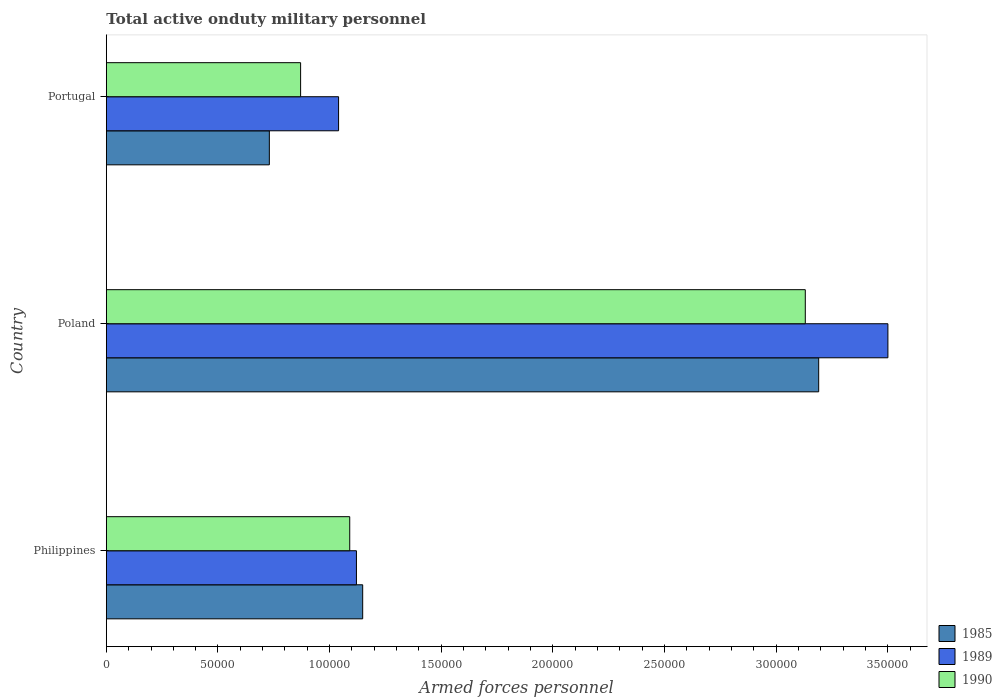How many groups of bars are there?
Your response must be concise. 3. Are the number of bars per tick equal to the number of legend labels?
Offer a very short reply. Yes. How many bars are there on the 3rd tick from the top?
Offer a terse response. 3. What is the label of the 2nd group of bars from the top?
Provide a short and direct response. Poland. What is the number of armed forces personnel in 1990 in Portugal?
Keep it short and to the point. 8.70e+04. Across all countries, what is the maximum number of armed forces personnel in 1985?
Your answer should be compact. 3.19e+05. Across all countries, what is the minimum number of armed forces personnel in 1985?
Your answer should be very brief. 7.30e+04. What is the total number of armed forces personnel in 1989 in the graph?
Give a very brief answer. 5.66e+05. What is the difference between the number of armed forces personnel in 1989 in Poland and that in Portugal?
Keep it short and to the point. 2.46e+05. What is the difference between the number of armed forces personnel in 1989 in Poland and the number of armed forces personnel in 1985 in Portugal?
Provide a short and direct response. 2.77e+05. What is the average number of armed forces personnel in 1989 per country?
Offer a very short reply. 1.89e+05. What is the difference between the number of armed forces personnel in 1985 and number of armed forces personnel in 1990 in Philippines?
Your answer should be very brief. 5800. In how many countries, is the number of armed forces personnel in 1989 greater than 190000 ?
Make the answer very short. 1. What is the ratio of the number of armed forces personnel in 1985 in Philippines to that in Portugal?
Your answer should be compact. 1.57. What is the difference between the highest and the second highest number of armed forces personnel in 1985?
Provide a succinct answer. 2.04e+05. What is the difference between the highest and the lowest number of armed forces personnel in 1990?
Provide a short and direct response. 2.26e+05. What does the 2nd bar from the bottom in Philippines represents?
Provide a short and direct response. 1989. What is the difference between two consecutive major ticks on the X-axis?
Your answer should be very brief. 5.00e+04. Are the values on the major ticks of X-axis written in scientific E-notation?
Give a very brief answer. No. Does the graph contain grids?
Offer a very short reply. No. Where does the legend appear in the graph?
Your answer should be very brief. Bottom right. What is the title of the graph?
Your answer should be compact. Total active onduty military personnel. What is the label or title of the X-axis?
Provide a short and direct response. Armed forces personnel. What is the label or title of the Y-axis?
Give a very brief answer. Country. What is the Armed forces personnel of 1985 in Philippines?
Your answer should be compact. 1.15e+05. What is the Armed forces personnel of 1989 in Philippines?
Your answer should be compact. 1.12e+05. What is the Armed forces personnel in 1990 in Philippines?
Keep it short and to the point. 1.09e+05. What is the Armed forces personnel of 1985 in Poland?
Your answer should be compact. 3.19e+05. What is the Armed forces personnel in 1989 in Poland?
Ensure brevity in your answer.  3.50e+05. What is the Armed forces personnel in 1990 in Poland?
Your response must be concise. 3.13e+05. What is the Armed forces personnel in 1985 in Portugal?
Offer a very short reply. 7.30e+04. What is the Armed forces personnel of 1989 in Portugal?
Provide a short and direct response. 1.04e+05. What is the Armed forces personnel in 1990 in Portugal?
Offer a terse response. 8.70e+04. Across all countries, what is the maximum Armed forces personnel in 1985?
Your answer should be very brief. 3.19e+05. Across all countries, what is the maximum Armed forces personnel in 1989?
Provide a succinct answer. 3.50e+05. Across all countries, what is the maximum Armed forces personnel in 1990?
Provide a short and direct response. 3.13e+05. Across all countries, what is the minimum Armed forces personnel in 1985?
Ensure brevity in your answer.  7.30e+04. Across all countries, what is the minimum Armed forces personnel of 1989?
Ensure brevity in your answer.  1.04e+05. Across all countries, what is the minimum Armed forces personnel of 1990?
Your answer should be very brief. 8.70e+04. What is the total Armed forces personnel of 1985 in the graph?
Your answer should be compact. 5.07e+05. What is the total Armed forces personnel in 1989 in the graph?
Ensure brevity in your answer.  5.66e+05. What is the total Armed forces personnel in 1990 in the graph?
Your response must be concise. 5.09e+05. What is the difference between the Armed forces personnel in 1985 in Philippines and that in Poland?
Provide a succinct answer. -2.04e+05. What is the difference between the Armed forces personnel in 1989 in Philippines and that in Poland?
Provide a short and direct response. -2.38e+05. What is the difference between the Armed forces personnel in 1990 in Philippines and that in Poland?
Offer a terse response. -2.04e+05. What is the difference between the Armed forces personnel of 1985 in Philippines and that in Portugal?
Offer a very short reply. 4.18e+04. What is the difference between the Armed forces personnel of 1989 in Philippines and that in Portugal?
Offer a very short reply. 8000. What is the difference between the Armed forces personnel in 1990 in Philippines and that in Portugal?
Your response must be concise. 2.20e+04. What is the difference between the Armed forces personnel of 1985 in Poland and that in Portugal?
Provide a short and direct response. 2.46e+05. What is the difference between the Armed forces personnel in 1989 in Poland and that in Portugal?
Ensure brevity in your answer.  2.46e+05. What is the difference between the Armed forces personnel in 1990 in Poland and that in Portugal?
Make the answer very short. 2.26e+05. What is the difference between the Armed forces personnel of 1985 in Philippines and the Armed forces personnel of 1989 in Poland?
Ensure brevity in your answer.  -2.35e+05. What is the difference between the Armed forces personnel in 1985 in Philippines and the Armed forces personnel in 1990 in Poland?
Keep it short and to the point. -1.98e+05. What is the difference between the Armed forces personnel of 1989 in Philippines and the Armed forces personnel of 1990 in Poland?
Your response must be concise. -2.01e+05. What is the difference between the Armed forces personnel in 1985 in Philippines and the Armed forces personnel in 1989 in Portugal?
Ensure brevity in your answer.  1.08e+04. What is the difference between the Armed forces personnel in 1985 in Philippines and the Armed forces personnel in 1990 in Portugal?
Offer a terse response. 2.78e+04. What is the difference between the Armed forces personnel of 1989 in Philippines and the Armed forces personnel of 1990 in Portugal?
Offer a terse response. 2.50e+04. What is the difference between the Armed forces personnel in 1985 in Poland and the Armed forces personnel in 1989 in Portugal?
Make the answer very short. 2.15e+05. What is the difference between the Armed forces personnel of 1985 in Poland and the Armed forces personnel of 1990 in Portugal?
Your answer should be very brief. 2.32e+05. What is the difference between the Armed forces personnel in 1989 in Poland and the Armed forces personnel in 1990 in Portugal?
Provide a succinct answer. 2.63e+05. What is the average Armed forces personnel of 1985 per country?
Keep it short and to the point. 1.69e+05. What is the average Armed forces personnel of 1989 per country?
Ensure brevity in your answer.  1.89e+05. What is the average Armed forces personnel of 1990 per country?
Your answer should be compact. 1.70e+05. What is the difference between the Armed forces personnel in 1985 and Armed forces personnel in 1989 in Philippines?
Keep it short and to the point. 2800. What is the difference between the Armed forces personnel in 1985 and Armed forces personnel in 1990 in Philippines?
Offer a very short reply. 5800. What is the difference between the Armed forces personnel of 1989 and Armed forces personnel of 1990 in Philippines?
Offer a terse response. 3000. What is the difference between the Armed forces personnel in 1985 and Armed forces personnel in 1989 in Poland?
Provide a succinct answer. -3.10e+04. What is the difference between the Armed forces personnel in 1985 and Armed forces personnel in 1990 in Poland?
Your answer should be compact. 6000. What is the difference between the Armed forces personnel in 1989 and Armed forces personnel in 1990 in Poland?
Provide a short and direct response. 3.70e+04. What is the difference between the Armed forces personnel in 1985 and Armed forces personnel in 1989 in Portugal?
Provide a short and direct response. -3.10e+04. What is the difference between the Armed forces personnel in 1985 and Armed forces personnel in 1990 in Portugal?
Give a very brief answer. -1.40e+04. What is the difference between the Armed forces personnel in 1989 and Armed forces personnel in 1990 in Portugal?
Offer a terse response. 1.70e+04. What is the ratio of the Armed forces personnel of 1985 in Philippines to that in Poland?
Offer a terse response. 0.36. What is the ratio of the Armed forces personnel in 1989 in Philippines to that in Poland?
Your answer should be very brief. 0.32. What is the ratio of the Armed forces personnel of 1990 in Philippines to that in Poland?
Provide a short and direct response. 0.35. What is the ratio of the Armed forces personnel in 1985 in Philippines to that in Portugal?
Provide a short and direct response. 1.57. What is the ratio of the Armed forces personnel in 1990 in Philippines to that in Portugal?
Your answer should be very brief. 1.25. What is the ratio of the Armed forces personnel of 1985 in Poland to that in Portugal?
Your answer should be very brief. 4.37. What is the ratio of the Armed forces personnel of 1989 in Poland to that in Portugal?
Your answer should be very brief. 3.37. What is the ratio of the Armed forces personnel of 1990 in Poland to that in Portugal?
Keep it short and to the point. 3.6. What is the difference between the highest and the second highest Armed forces personnel of 1985?
Provide a succinct answer. 2.04e+05. What is the difference between the highest and the second highest Armed forces personnel of 1989?
Offer a very short reply. 2.38e+05. What is the difference between the highest and the second highest Armed forces personnel of 1990?
Give a very brief answer. 2.04e+05. What is the difference between the highest and the lowest Armed forces personnel of 1985?
Ensure brevity in your answer.  2.46e+05. What is the difference between the highest and the lowest Armed forces personnel of 1989?
Provide a short and direct response. 2.46e+05. What is the difference between the highest and the lowest Armed forces personnel of 1990?
Offer a terse response. 2.26e+05. 